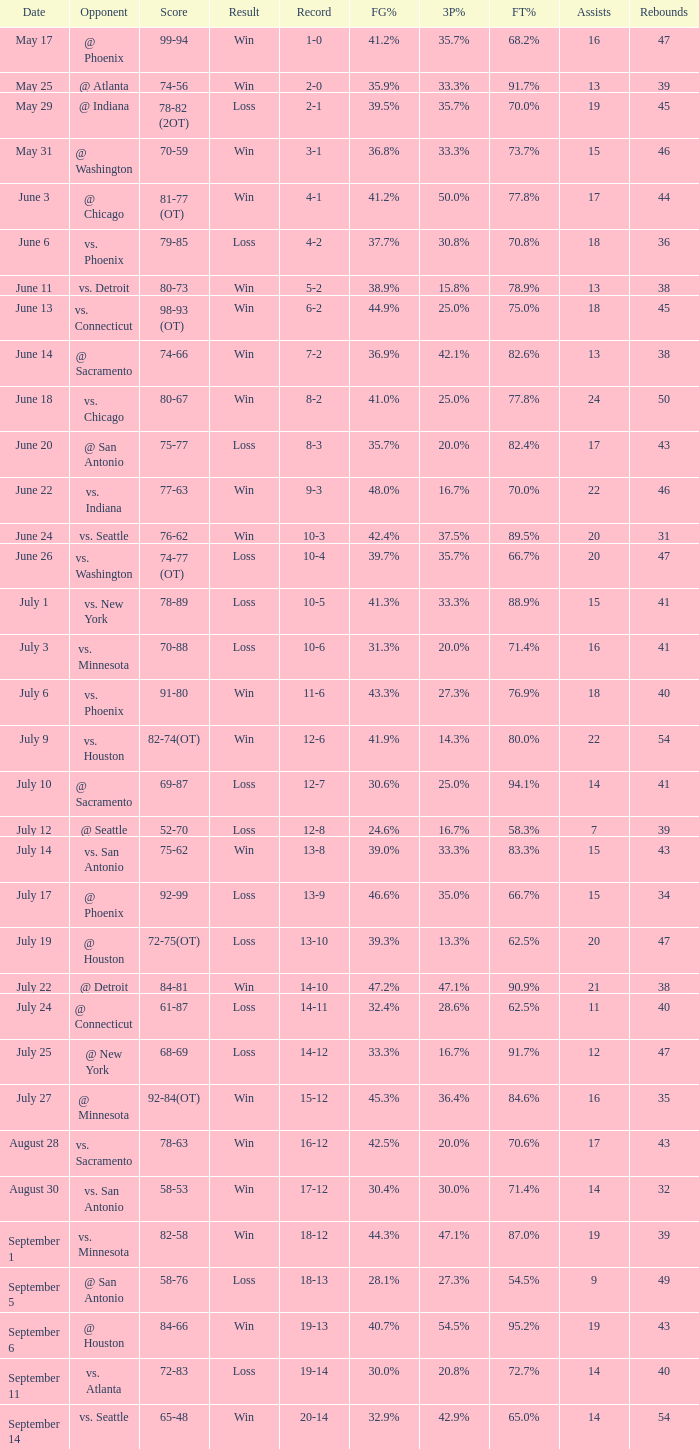Parse the full table. {'header': ['Date', 'Opponent', 'Score', 'Result', 'Record', 'FG%', '3P%', 'FT%', 'Assists', 'Rebounds'], 'rows': [['May 17', '@ Phoenix', '99-94', 'Win', '1-0', '41.2%', '35.7%', '68.2%', '16', '47'], ['May 25', '@ Atlanta', '74-56', 'Win', '2-0', '35.9%', '33.3%', '91.7%', '13', '39'], ['May 29', '@ Indiana', '78-82 (2OT)', 'Loss', '2-1', '39.5%', '35.7%', '70.0%', '19', '45'], ['May 31', '@ Washington', '70-59', 'Win', '3-1', '36.8%', '33.3%', '73.7%', '15', '46'], ['June 3', '@ Chicago', '81-77 (OT)', 'Win', '4-1', '41.2%', '50.0%', '77.8%', '17', '44'], ['June 6', 'vs. Phoenix', '79-85', 'Loss', '4-2', '37.7%', '30.8%', '70.8%', '18', '36'], ['June 11', 'vs. Detroit', '80-73', 'Win', '5-2', '38.9%', '15.8%', '78.9%', '13', '38'], ['June 13', 'vs. Connecticut', '98-93 (OT)', 'Win', '6-2', '44.9%', '25.0%', '75.0%', '18', '45'], ['June 14', '@ Sacramento', '74-66', 'Win', '7-2', '36.9%', '42.1%', '82.6%', '13', '38'], ['June 18', 'vs. Chicago', '80-67', 'Win', '8-2', '41.0%', '25.0%', '77.8%', '24', '50'], ['June 20', '@ San Antonio', '75-77', 'Loss', '8-3', '35.7%', '20.0%', '82.4%', '17', '43'], ['June 22', 'vs. Indiana', '77-63', 'Win', '9-3', '48.0%', '16.7%', '70.0%', '22', '46'], ['June 24', 'vs. Seattle', '76-62', 'Win', '10-3', '42.4%', '37.5%', '89.5%', '20', '31'], ['June 26', 'vs. Washington', '74-77 (OT)', 'Loss', '10-4', '39.7%', '35.7%', '66.7%', '20', '47'], ['July 1', 'vs. New York', '78-89', 'Loss', '10-5', '41.3%', '33.3%', '88.9%', '15', '41'], ['July 3', 'vs. Minnesota', '70-88', 'Loss', '10-6', '31.3%', '20.0%', '71.4%', '16', '41'], ['July 6', 'vs. Phoenix', '91-80', 'Win', '11-6', '43.3%', '27.3%', '76.9%', '18', '40'], ['July 9', 'vs. Houston', '82-74(OT)', 'Win', '12-6', '41.9%', '14.3%', '80.0%', '22', '54'], ['July 10', '@ Sacramento', '69-87', 'Loss', '12-7', '30.6%', '25.0%', '94.1%', '14', '41'], ['July 12', '@ Seattle', '52-70', 'Loss', '12-8', '24.6%', '16.7%', '58.3%', '7', '39'], ['July 14', 'vs. San Antonio', '75-62', 'Win', '13-8', '39.0%', '33.3%', '83.3%', '15', '43'], ['July 17', '@ Phoenix', '92-99', 'Loss', '13-9', '46.6%', '35.0%', '66.7%', '15', '34'], ['July 19', '@ Houston', '72-75(OT)', 'Loss', '13-10', '39.3%', '13.3%', '62.5%', '20', '47'], ['July 22', '@ Detroit', '84-81', 'Win', '14-10', '47.2%', '47.1%', '90.9%', '21', '38'], ['July 24', '@ Connecticut', '61-87', 'Loss', '14-11', '32.4%', '28.6%', '62.5%', '11', '40'], ['July 25', '@ New York', '68-69', 'Loss', '14-12', '33.3%', '16.7%', '91.7%', '12', '47'], ['July 27', '@ Minnesota', '92-84(OT)', 'Win', '15-12', '45.3%', '36.4%', '84.6%', '16', '35'], ['August 28', 'vs. Sacramento', '78-63', 'Win', '16-12', '42.5%', '20.0%', '70.6%', '17', '43'], ['August 30', 'vs. San Antonio', '58-53', 'Win', '17-12', '30.4%', '30.0%', '71.4%', '14', '32'], ['September 1', 'vs. Minnesota', '82-58', 'Win', '18-12', '44.3%', '47.1%', '87.0%', '19', '39'], ['September 5', '@ San Antonio', '58-76', 'Loss', '18-13', '28.1%', '27.3%', '54.5%', '9', '49'], ['September 6', '@ Houston', '84-66', 'Win', '19-13', '40.7%', '54.5%', '95.2%', '19', '43'], ['September 11', 'vs. Atlanta', '72-83', 'Loss', '19-14', '30.0%', '20.8%', '72.7%', '14', '40'], ['September 14', 'vs. Seattle', '65-48', 'Win', '20-14', '32.9%', '42.9%', '65.0%', '14', '54']]} What is the Record of the game with a Score of 65-48? 20-14. 